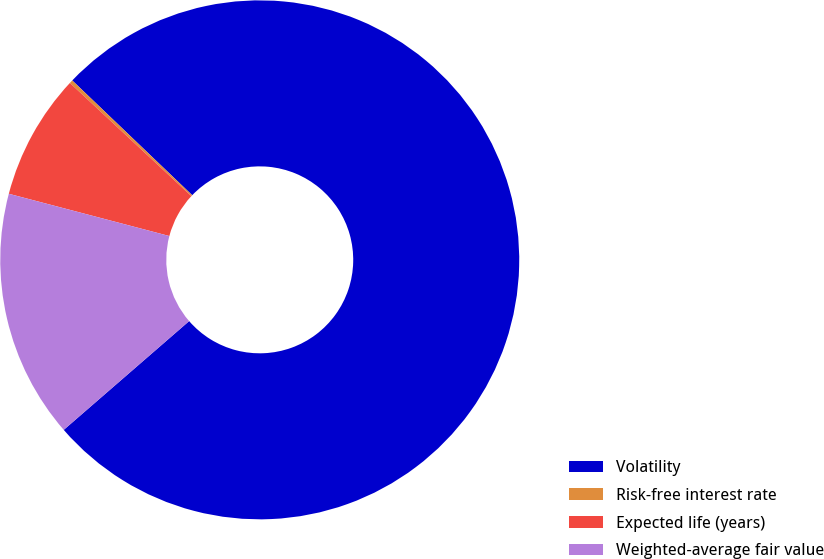Convert chart. <chart><loc_0><loc_0><loc_500><loc_500><pie_chart><fcel>Volatility<fcel>Risk-free interest rate<fcel>Expected life (years)<fcel>Weighted-average fair value<nl><fcel>76.48%<fcel>0.21%<fcel>7.84%<fcel>15.47%<nl></chart> 